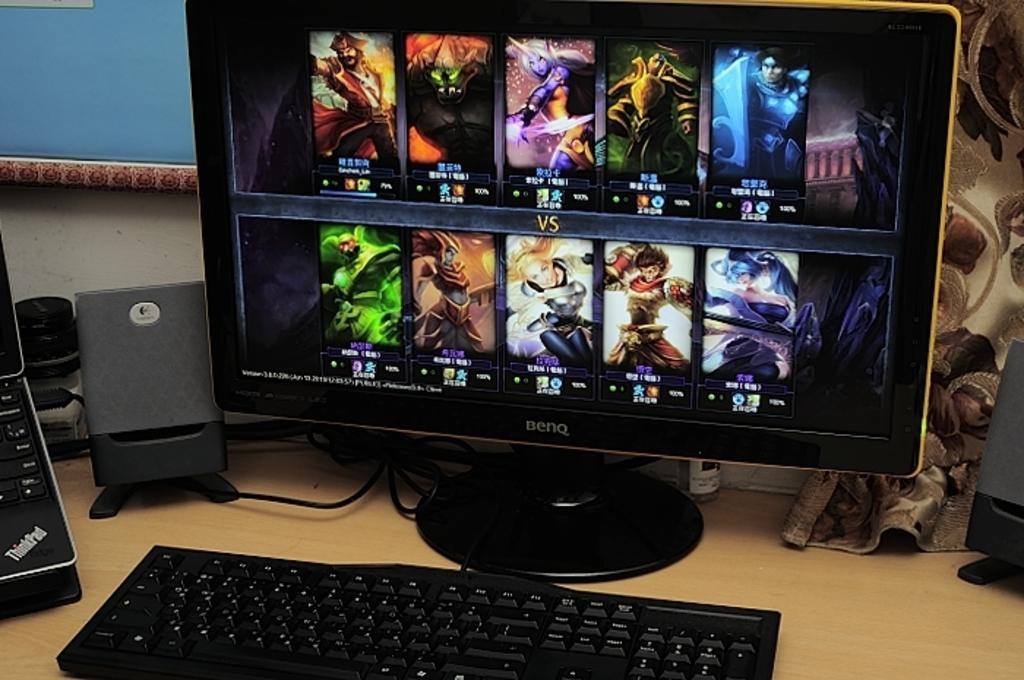<image>
Share a concise interpretation of the image provided. A BenQ monitor showing several different photos on the screen. 